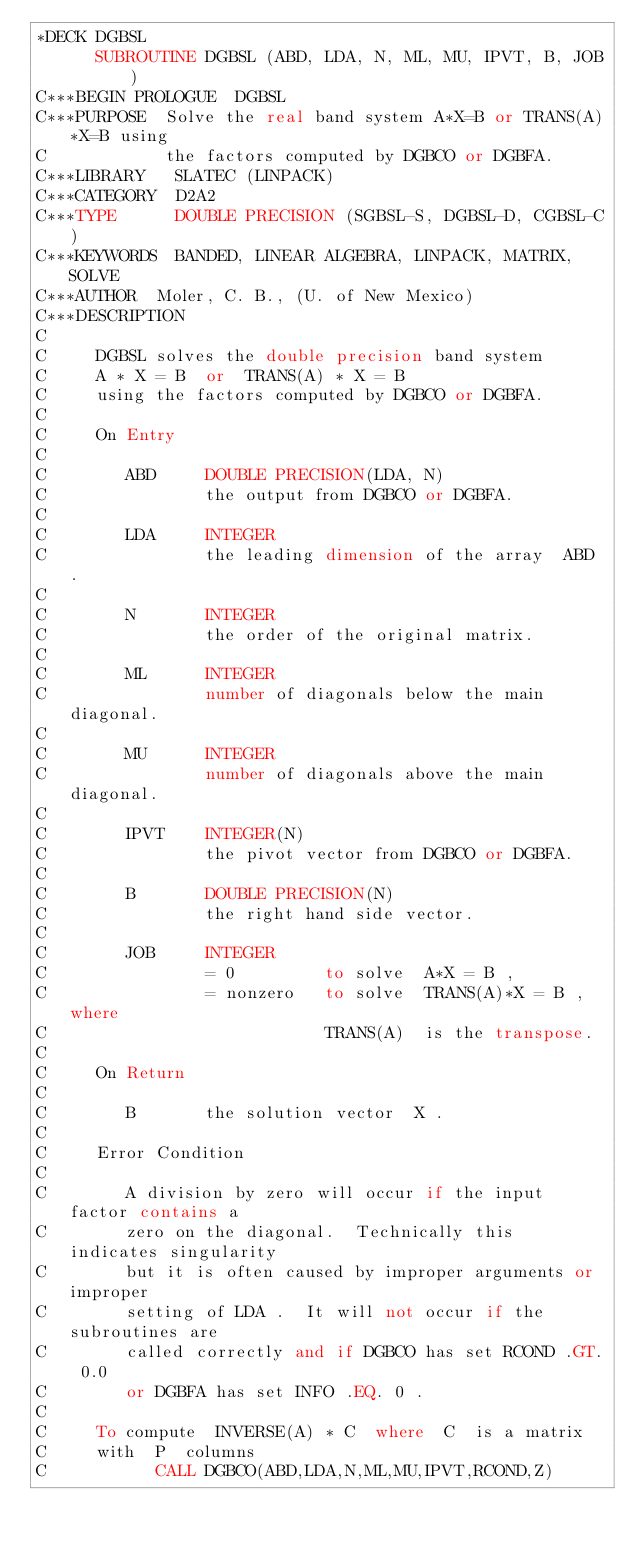<code> <loc_0><loc_0><loc_500><loc_500><_FORTRAN_>*DECK DGBSL
      SUBROUTINE DGBSL (ABD, LDA, N, ML, MU, IPVT, B, JOB)
C***BEGIN PROLOGUE  DGBSL
C***PURPOSE  Solve the real band system A*X=B or TRANS(A)*X=B using
C            the factors computed by DGBCO or DGBFA.
C***LIBRARY   SLATEC (LINPACK)
C***CATEGORY  D2A2
C***TYPE      DOUBLE PRECISION (SGBSL-S, DGBSL-D, CGBSL-C)
C***KEYWORDS  BANDED, LINEAR ALGEBRA, LINPACK, MATRIX, SOLVE
C***AUTHOR  Moler, C. B., (U. of New Mexico)
C***DESCRIPTION
C
C     DGBSL solves the double precision band system
C     A * X = B  or  TRANS(A) * X = B
C     using the factors computed by DGBCO or DGBFA.
C
C     On Entry
C
C        ABD     DOUBLE PRECISION(LDA, N)
C                the output from DGBCO or DGBFA.
C
C        LDA     INTEGER
C                the leading dimension of the array  ABD .
C
C        N       INTEGER
C                the order of the original matrix.
C
C        ML      INTEGER
C                number of diagonals below the main diagonal.
C
C        MU      INTEGER
C                number of diagonals above the main diagonal.
C
C        IPVT    INTEGER(N)
C                the pivot vector from DGBCO or DGBFA.
C
C        B       DOUBLE PRECISION(N)
C                the right hand side vector.
C
C        JOB     INTEGER
C                = 0         to solve  A*X = B ,
C                = nonzero   to solve  TRANS(A)*X = B , where
C                            TRANS(A)  is the transpose.
C
C     On Return
C
C        B       the solution vector  X .
C
C     Error Condition
C
C        A division by zero will occur if the input factor contains a
C        zero on the diagonal.  Technically this indicates singularity
C        but it is often caused by improper arguments or improper
C        setting of LDA .  It will not occur if the subroutines are
C        called correctly and if DGBCO has set RCOND .GT. 0.0
C        or DGBFA has set INFO .EQ. 0 .
C
C     To compute  INVERSE(A) * C  where  C  is a matrix
C     with  P  columns
C           CALL DGBCO(ABD,LDA,N,ML,MU,IPVT,RCOND,Z)</code> 